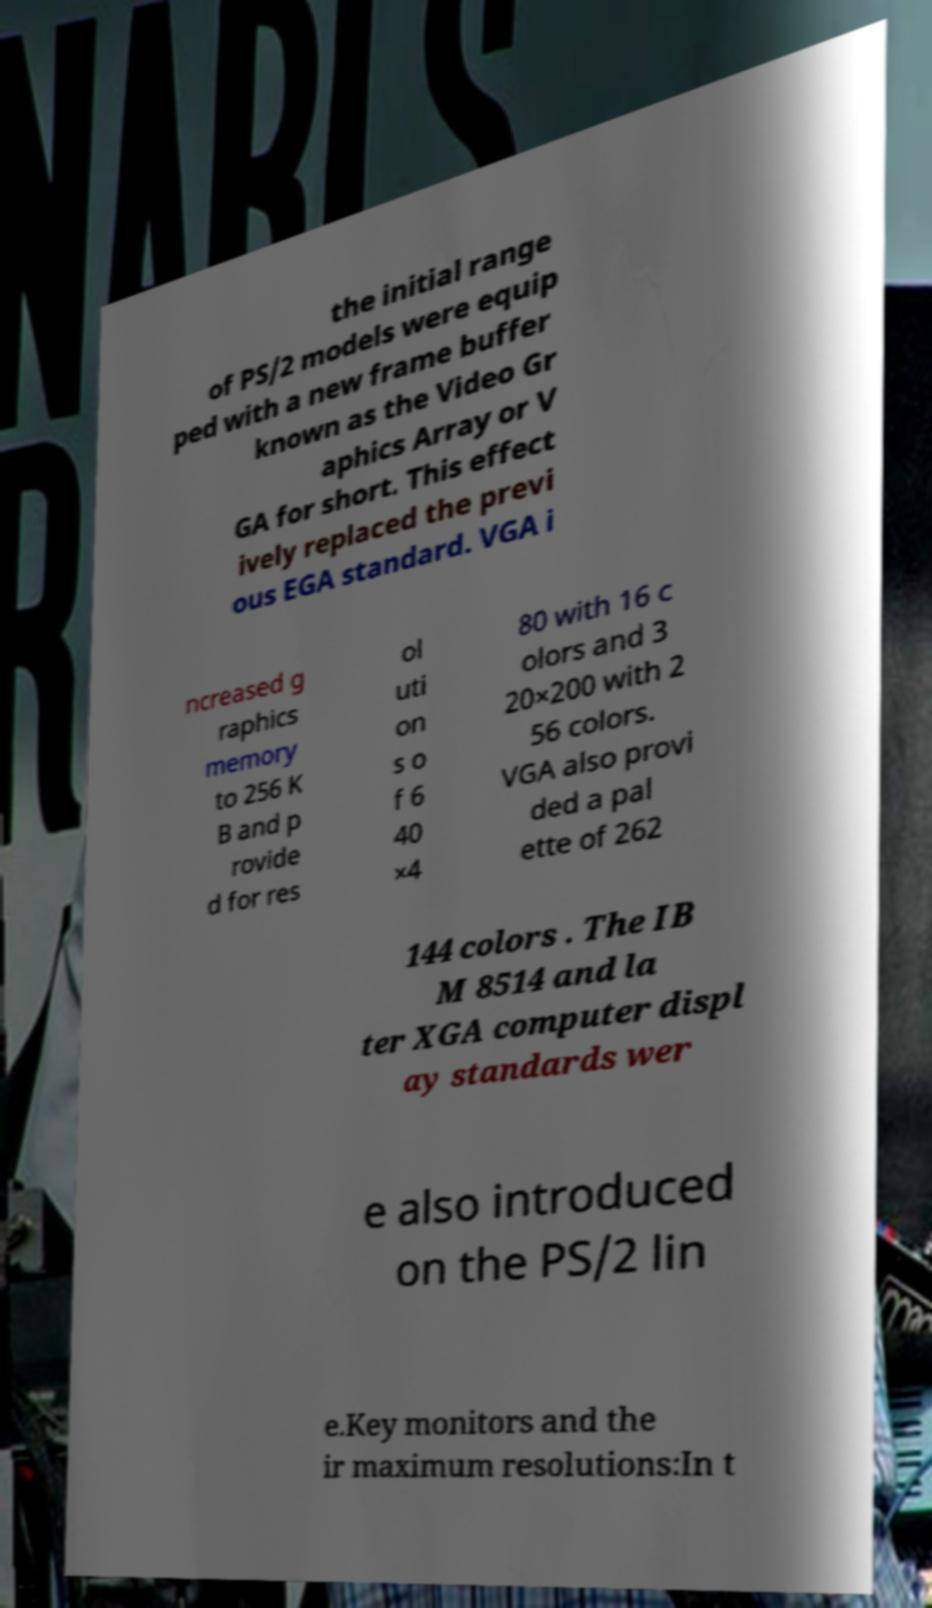Can you read and provide the text displayed in the image?This photo seems to have some interesting text. Can you extract and type it out for me? the initial range of PS/2 models were equip ped with a new frame buffer known as the Video Gr aphics Array or V GA for short. This effect ively replaced the previ ous EGA standard. VGA i ncreased g raphics memory to 256 K B and p rovide d for res ol uti on s o f 6 40 ×4 80 with 16 c olors and 3 20×200 with 2 56 colors. VGA also provi ded a pal ette of 262 144 colors . The IB M 8514 and la ter XGA computer displ ay standards wer e also introduced on the PS/2 lin e.Key monitors and the ir maximum resolutions:In t 